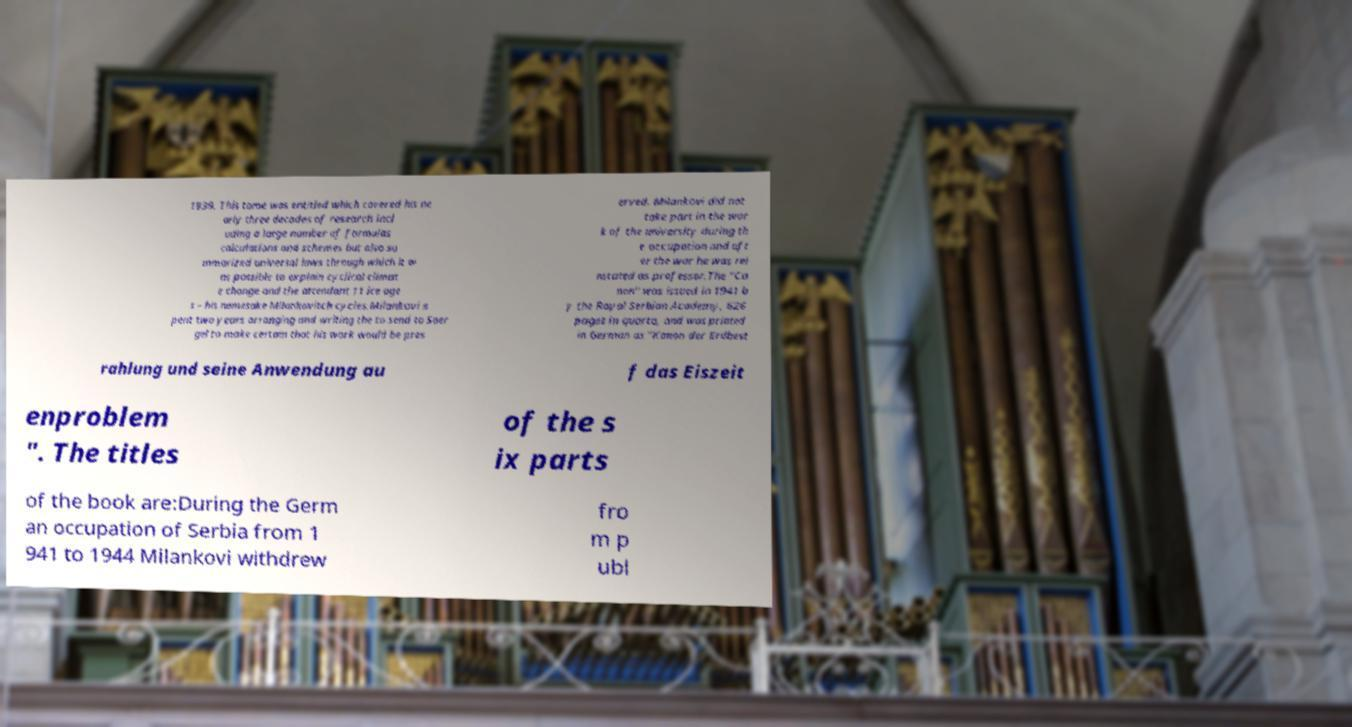Please identify and transcribe the text found in this image. 1939. This tome was entitled which covered his ne arly three decades of research incl uding a large number of formulas calculations and schemes but also su mmarized universal laws through which it w as possible to explain cyclical climat e change and the attendant 11 ice age s – his namesake Milankovitch cycles.Milankovi s pent two years arranging and writing the to send to Soer gel to make certain that his work would be pres erved. Milankovi did not take part in the wor k of the university during th e occupation and aft er the war he was rei nstated as professor.The "Ca non" was issued in 1941 b y the Royal Serbian Academy, 626 pages in quarto, and was printed in German as "Kanon der Erdbest rahlung und seine Anwendung au f das Eiszeit enproblem ". The titles of the s ix parts of the book are:During the Germ an occupation of Serbia from 1 941 to 1944 Milankovi withdrew fro m p ubl 